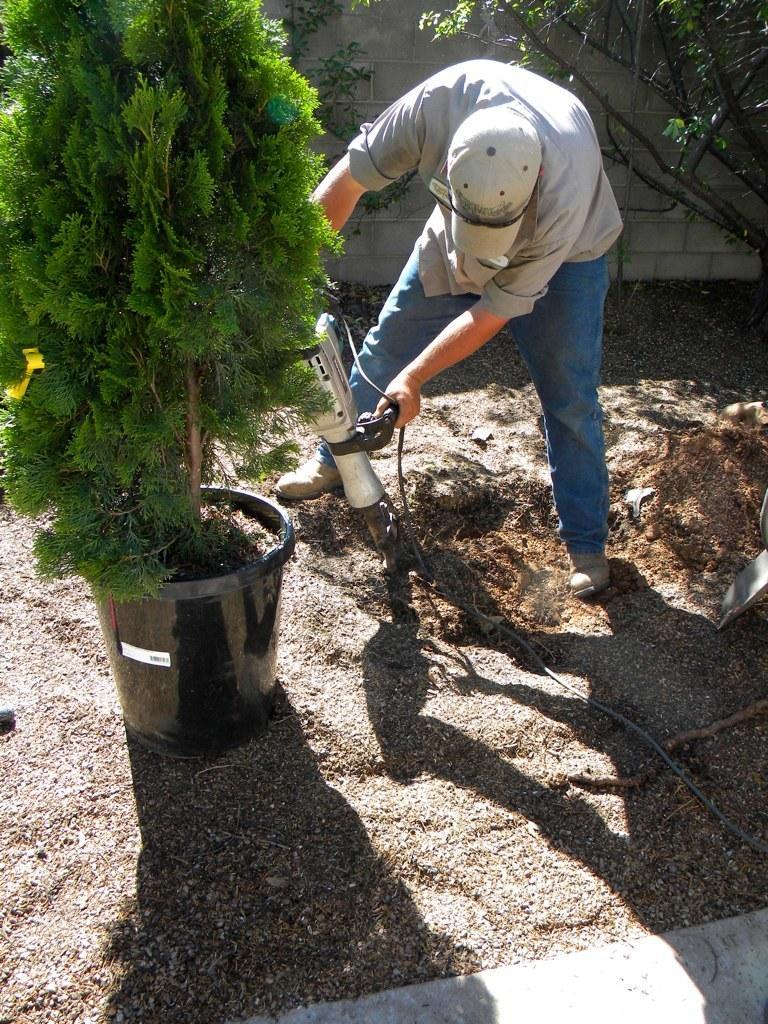Please provide a concise description of this image. In the center of the image there is a plant. There is a person using a drilling machine. At the bottom of the image there is ground. In the background of the image there is wall. 